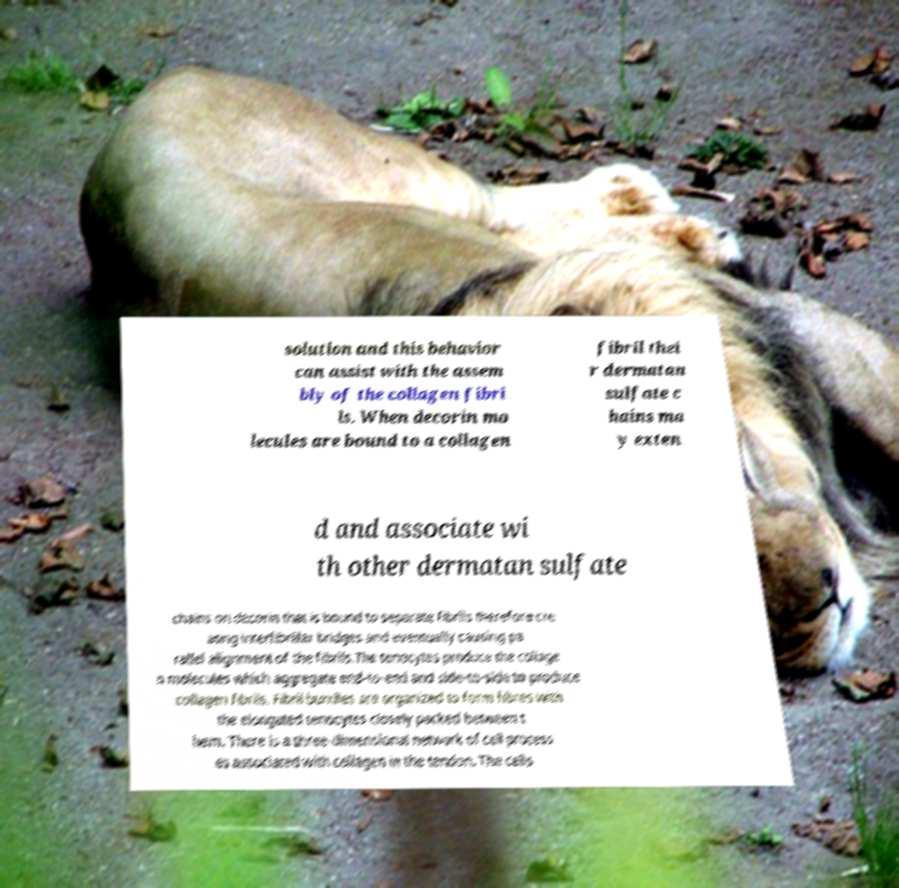Please identify and transcribe the text found in this image. solution and this behavior can assist with the assem bly of the collagen fibri ls. When decorin mo lecules are bound to a collagen fibril thei r dermatan sulfate c hains ma y exten d and associate wi th other dermatan sulfate chains on decorin that is bound to separate fibrils therefore cre ating interfibrillar bridges and eventually causing pa rallel alignment of the fibrils.The tenocytes produce the collage n molecules which aggregate end-to-end and side-to-side to produce collagen fibrils. Fibril bundles are organized to form fibres with the elongated tenocytes closely packed between t hem. There is a three-dimensional network of cell process es associated with collagen in the tendon. The cells 